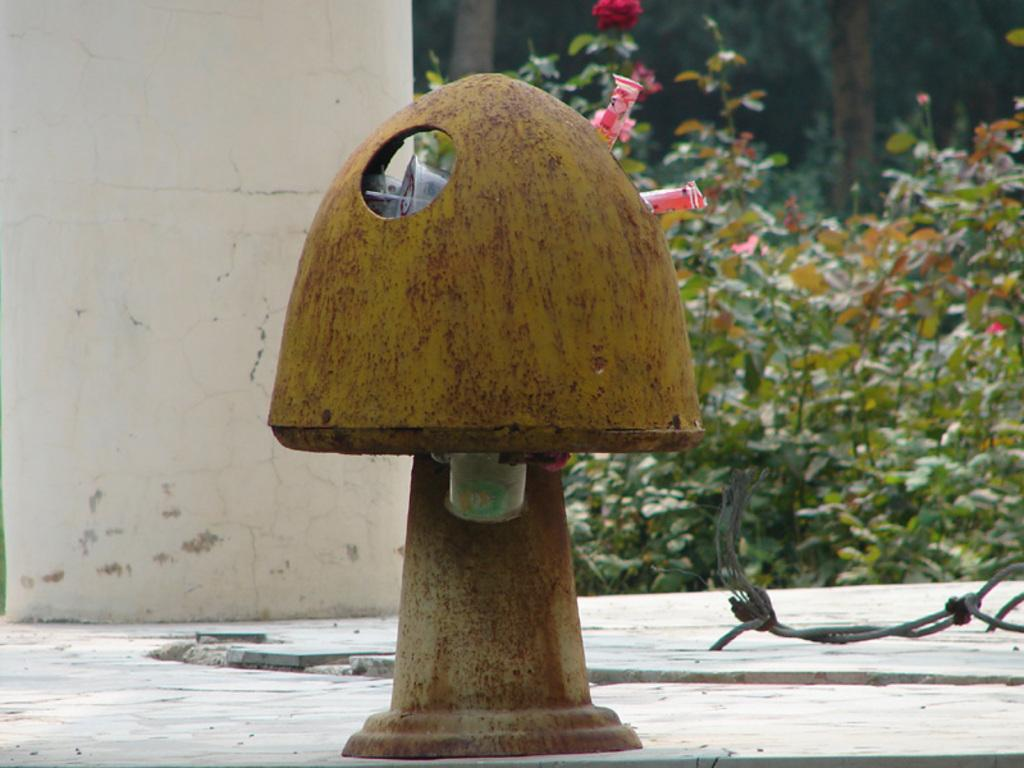What object is present in the image that is used for waste disposal? There is a dustbin in the image. Where is the dustbin located? The dustbin is on the land. What can be seen on the left side of the image? There is a wall on the left side of the image. What type of vegetation is visible behind the wall? There are plants behind the wall. How many bottles are hanging from the wall in the image? There are no bottles hanging from the wall in the image. What type of birds can be seen flying near the plants in the image? There are no birds visible in the image; it only features a dustbin, land, wall, and plants. 